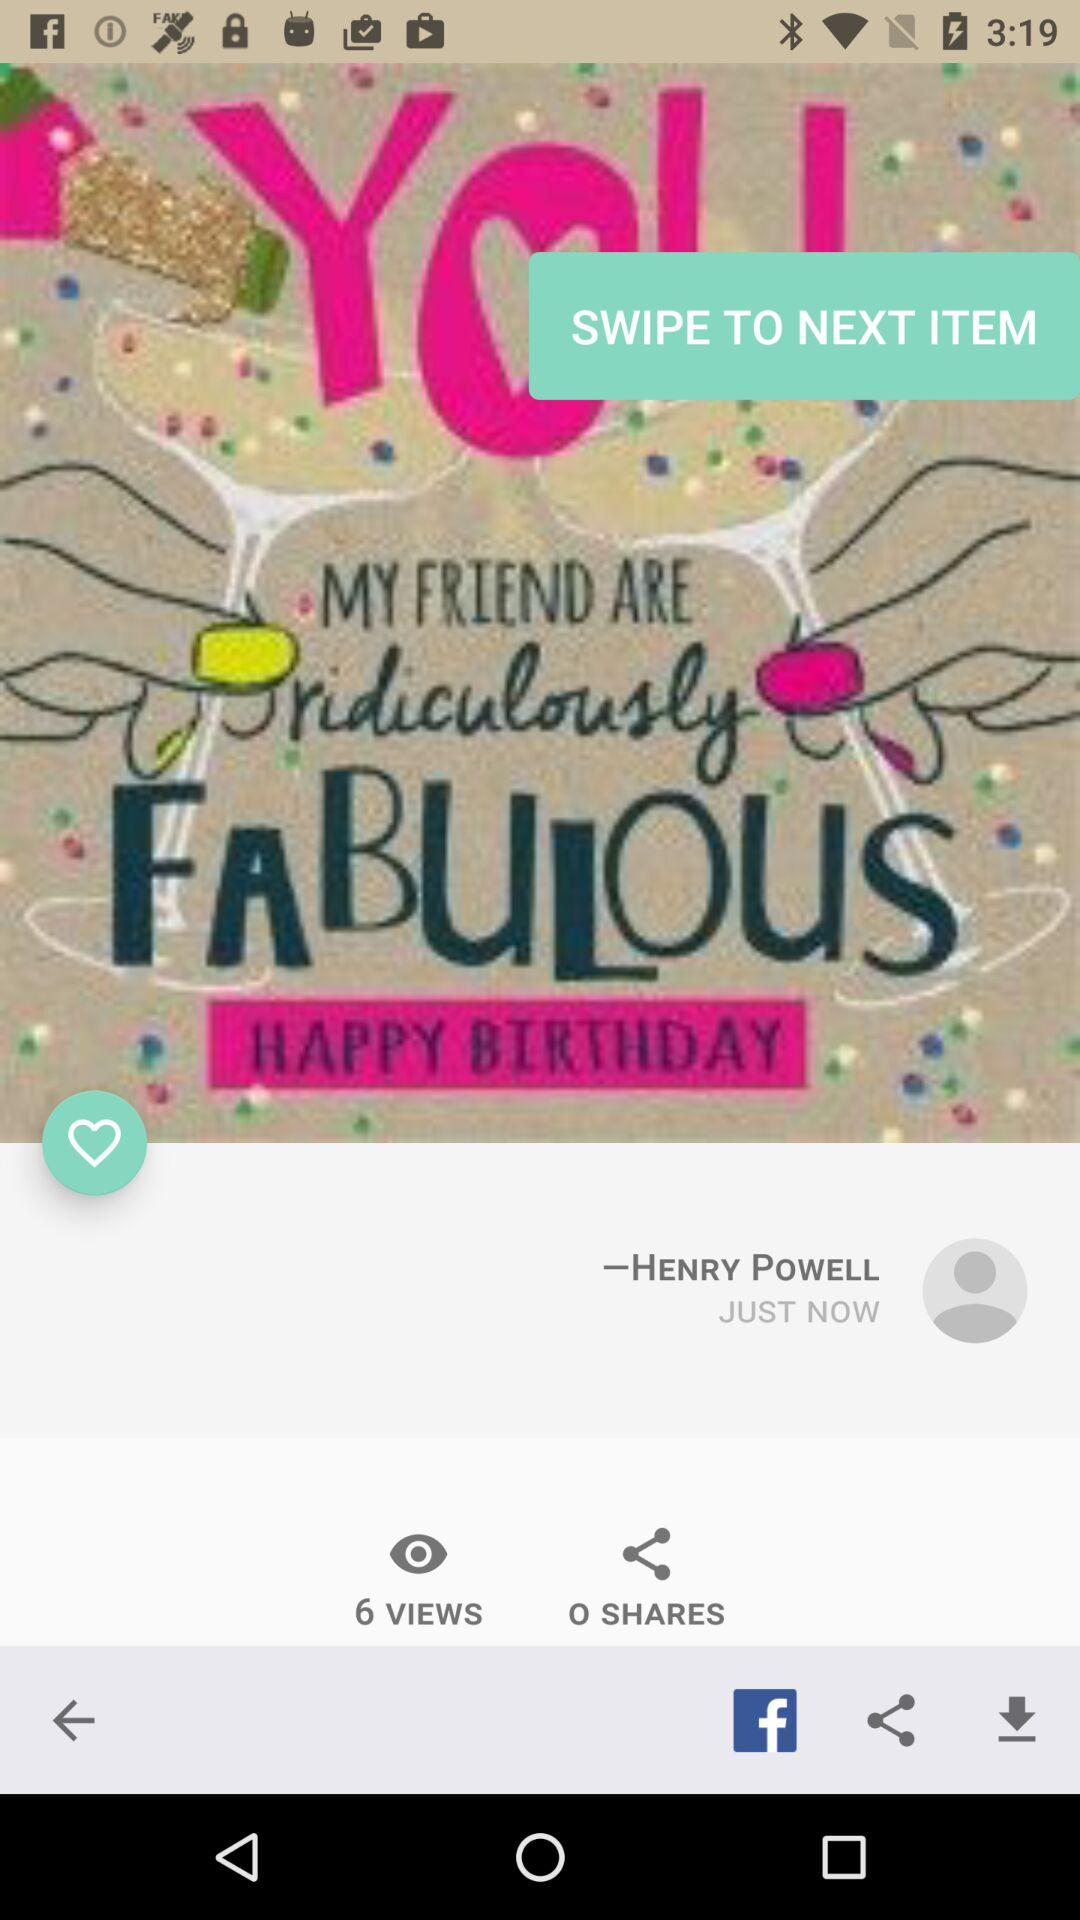How many total views did the photo get? The total views are 6. 